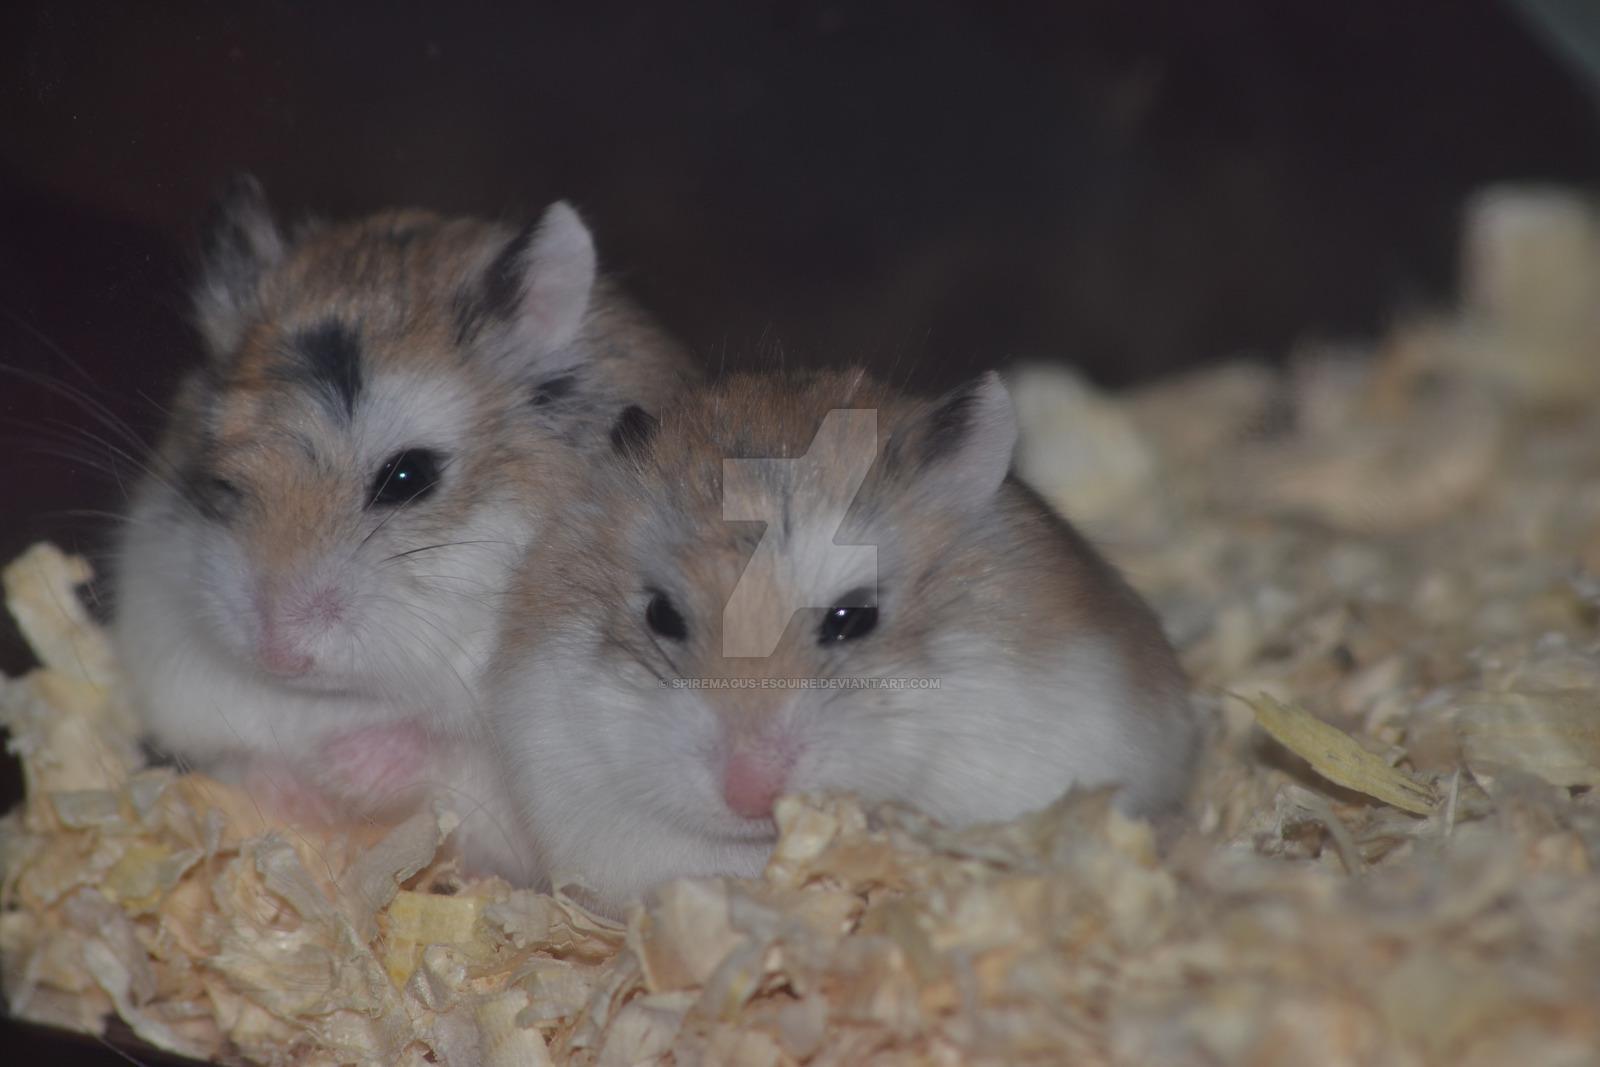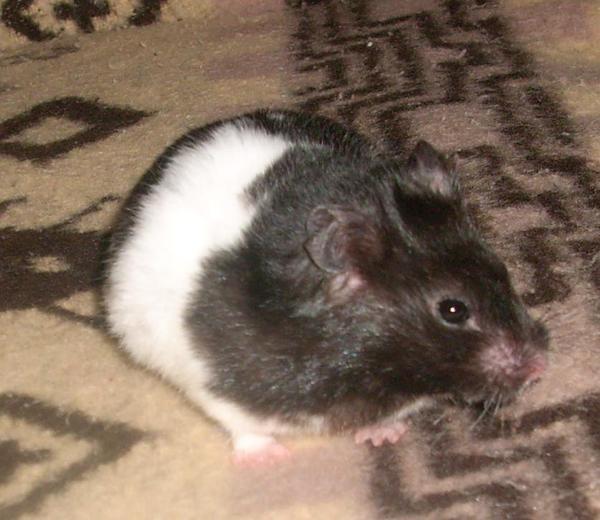The first image is the image on the left, the second image is the image on the right. For the images displayed, is the sentence "At least one hamster is sitting on wood shavings." factually correct? Answer yes or no. Yes. The first image is the image on the left, the second image is the image on the right. Considering the images on both sides, is "The image pair contains one hamster in the left image and two hamsters in the right image." valid? Answer yes or no. No. 